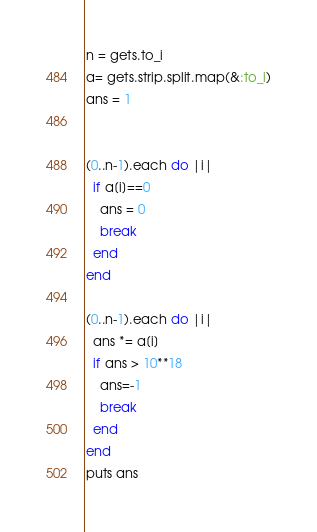<code> <loc_0><loc_0><loc_500><loc_500><_Ruby_>n = gets.to_i
a= gets.strip.split.map(&:to_i)
ans = 1


(0..n-1).each do |i|
  if a[i]==0
    ans = 0
    break
  end
end

(0..n-1).each do |i|
  ans *= a[i]  
  if ans > 10**18
    ans=-1
    break
  end
end
puts ans
</code> 